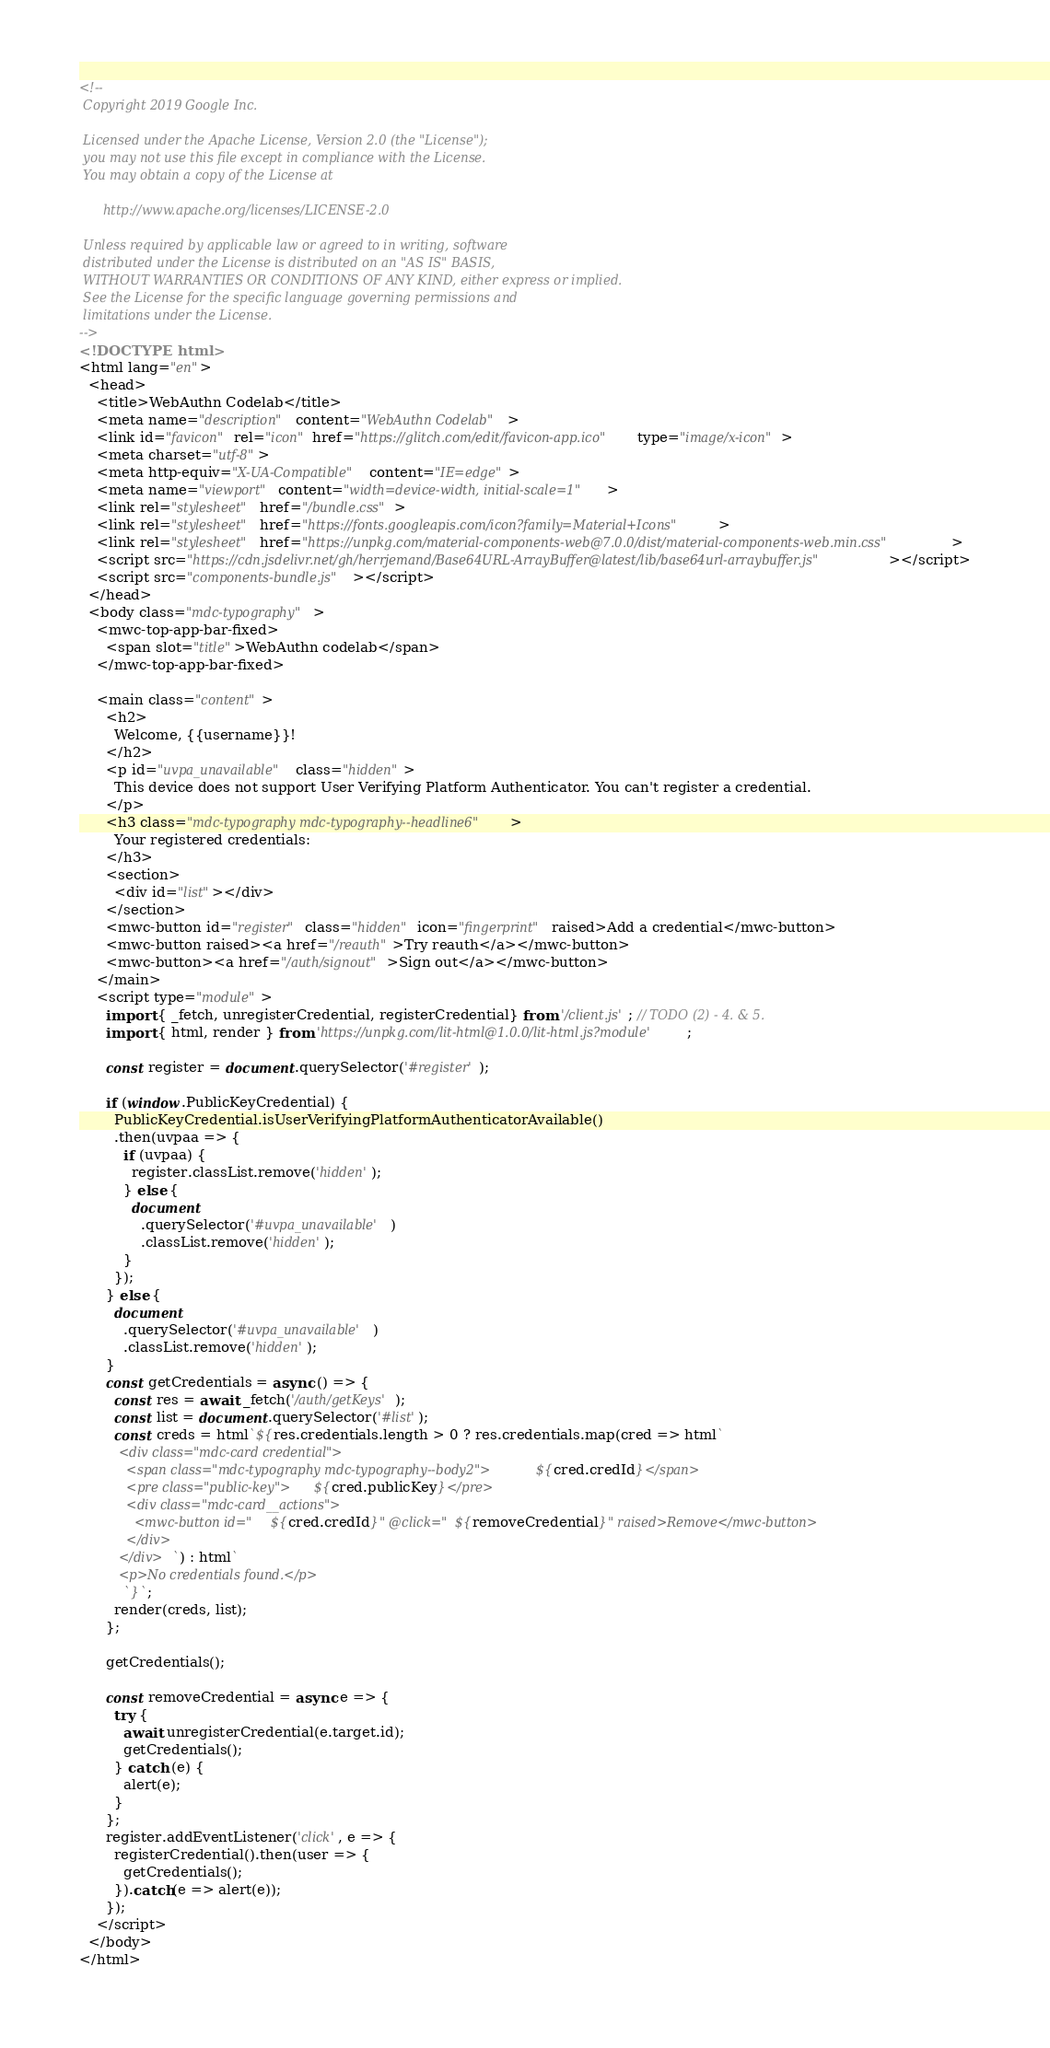Convert code to text. <code><loc_0><loc_0><loc_500><loc_500><_HTML_><!--
 Copyright 2019 Google Inc.

 Licensed under the Apache License, Version 2.0 (the "License");
 you may not use this file except in compliance with the License.
 You may obtain a copy of the License at

      http://www.apache.org/licenses/LICENSE-2.0

 Unless required by applicable law or agreed to in writing, software
 distributed under the License is distributed on an "AS IS" BASIS,
 WITHOUT WARRANTIES OR CONDITIONS OF ANY KIND, either express or implied.
 See the License for the specific language governing permissions and
 limitations under the License.
-->
<!DOCTYPE html>
<html lang="en">
  <head>
    <title>WebAuthn Codelab</title>
    <meta name="description" content="WebAuthn Codelab">
    <link id="favicon" rel="icon" href="https://glitch.com/edit/favicon-app.ico" type="image/x-icon">
    <meta charset="utf-8">
    <meta http-equiv="X-UA-Compatible" content="IE=edge">
    <meta name="viewport" content="width=device-width, initial-scale=1">
    <link rel="stylesheet" href="/bundle.css">
    <link rel="stylesheet" href="https://fonts.googleapis.com/icon?family=Material+Icons">
    <link rel="stylesheet" href="https://unpkg.com/material-components-web@7.0.0/dist/material-components-web.min.css">
    <script src="https://cdn.jsdelivr.net/gh/herrjemand/Base64URL-ArrayBuffer@latest/lib/base64url-arraybuffer.js"></script>
    <script src="components-bundle.js"></script>
  </head>
  <body class="mdc-typography">
    <mwc-top-app-bar-fixed>
      <span slot="title">WebAuthn codelab</span>
    </mwc-top-app-bar-fixed>

    <main class="content">
      <h2>
        Welcome, {{username}}!
      </h2>
      <p id="uvpa_unavailable" class="hidden">
        This device does not support User Verifying Platform Authenticator. You can't register a credential.
      </p>
      <h3 class="mdc-typography mdc-typography--headline6">
        Your registered credentials:
      </h3>
      <section>
        <div id="list"></div>
      </section>
      <mwc-button id="register" class="hidden" icon="fingerprint" raised>Add a credential</mwc-button>
      <mwc-button raised><a href="/reauth">Try reauth</a></mwc-button>
      <mwc-button><a href="/auth/signout">Sign out</a></mwc-button>
    </main>
    <script type="module">
      import { _fetch, unregisterCredential, registerCredential} from '/client.js'; // TODO (2) - 4. & 5.
      import { html, render } from 'https://unpkg.com/lit-html@1.0.0/lit-html.js?module';

      const register = document.querySelector('#register');

      if (window.PublicKeyCredential) {
        PublicKeyCredential.isUserVerifyingPlatformAuthenticatorAvailable()
        .then(uvpaa => {
          if (uvpaa) {
            register.classList.remove('hidden');
          } else {
            document
              .querySelector('#uvpa_unavailable')
              .classList.remove('hidden');
          }
        });        
      } else {
        document
          .querySelector('#uvpa_unavailable')
          .classList.remove('hidden');
      }
      const getCredentials = async () => {
        const res = await _fetch('/auth/getKeys');
        const list = document.querySelector('#list');
        const creds = html`${res.credentials.length > 0 ? res.credentials.map(cred => html`
          <div class="mdc-card credential">
            <span class="mdc-typography mdc-typography--body2">${cred.credId}</span>
            <pre class="public-key">${cred.publicKey}</pre>
            <div class="mdc-card__actions">
              <mwc-button id="${cred.credId}" @click="${removeCredential}" raised>Remove</mwc-button>
            </div>
          </div>`) : html`
          <p>No credentials found.</p>
          `}`;
        render(creds, list);
      };
      
      getCredentials();
      
      const removeCredential = async e => {
        try {
          await unregisterCredential(e.target.id);
          getCredentials();
        } catch (e) {
          alert(e);
        }
      };
      register.addEventListener('click', e => {
        registerCredential().then(user => {
          getCredentials();
        }).catch(e => alert(e));
      });
    </script>
  </body>
</html>
</code> 